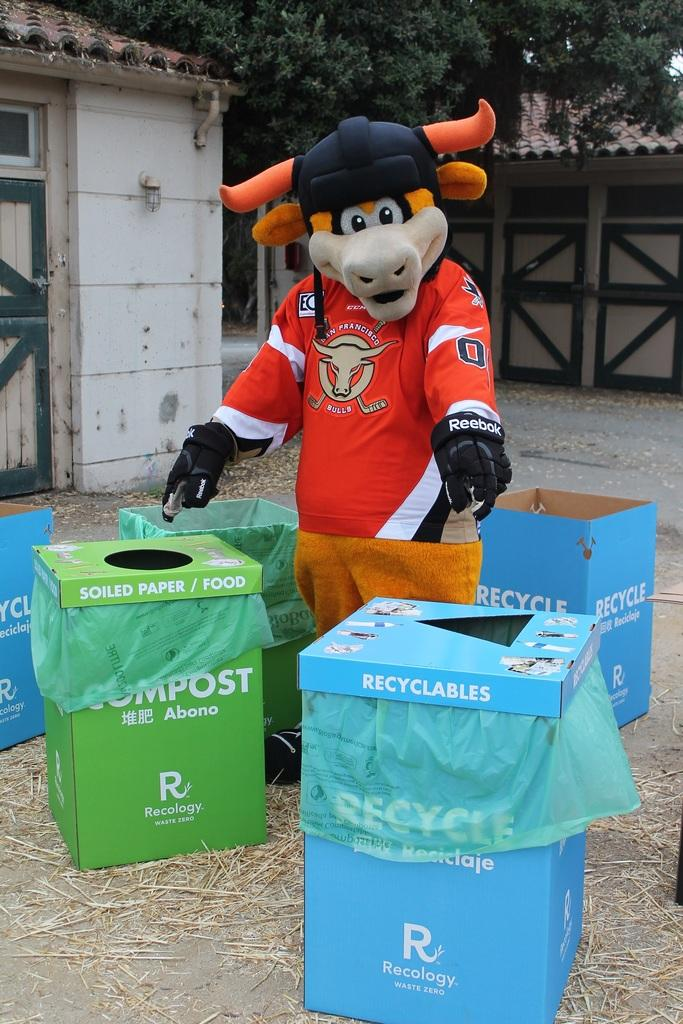Provide a one-sentence caption for the provided image. A mascot for the San Francisco Bulls standing in the middle of Recycle and Compost disposal bins pointing to them. 